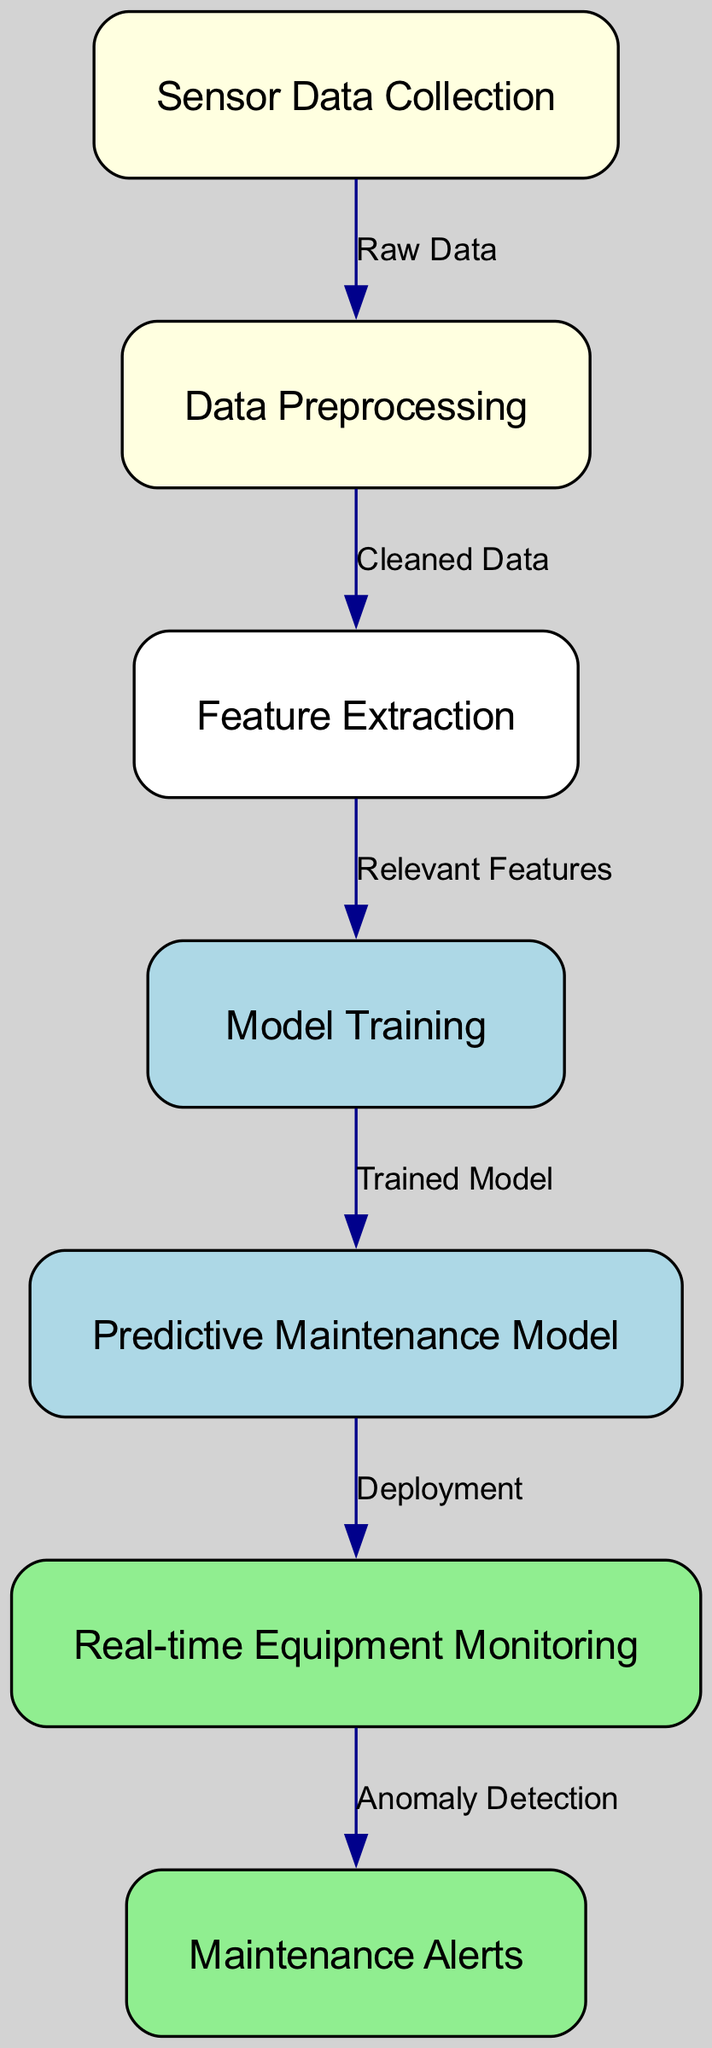What is the first step in the diagram? The first node in the diagram is "Sensor Data Collection," which is where the process begins by gathering raw data from equipment sensors.
Answer: Sensor Data Collection How many nodes are in the diagram? By counting all displayed nodes, a total of seven nodes are present.
Answer: 7 What type of data is fed into data preprocessing? The edge from "Sensor Data Collection" to "Data Preprocessing" indicates that "Raw Data" is the input.
Answer: Raw Data Which node represents the output of model training? The "Trained Model" node directly follows the "Model Training" node, indicating its output.
Answer: Trained Model What is the final output of the predictive maintenance process? The last node in the flow is "Maintenance Alerts," which signifies the final output of the process that alerts maintenance teams.
Answer: Maintenance Alerts Which node indicates the deployment stage? The transition from "Predictive Maintenance Model" to "Real-time Equipment Monitoring" represents where the model is deployed for use.
Answer: Real-time Equipment Monitoring How does predictive maintenance detect issues? The edge from "Real-time Equipment Monitoring" to "Maintenance Alerts" specifies "Anomaly Detection," which is how issues are identified.
Answer: Anomaly Detection What kind of data is transformed during feature extraction? The nodes indicate that "Relevant Features" are produced from the "Cleaned Data" after preprocessing.
Answer: Relevant Features What is the relationship between feature extraction and model training? The edge linking "Feature Extraction" to "Model Training" shows that the "Relevant Features" are used as input for training the model.
Answer: Relevant Features 